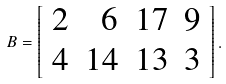Convert formula to latex. <formula><loc_0><loc_0><loc_500><loc_500>B = \left [ \begin{array} { r r r r } 2 & 6 & 1 7 & 9 \\ 4 & 1 4 & 1 3 & 3 \end{array} \right ] .</formula> 